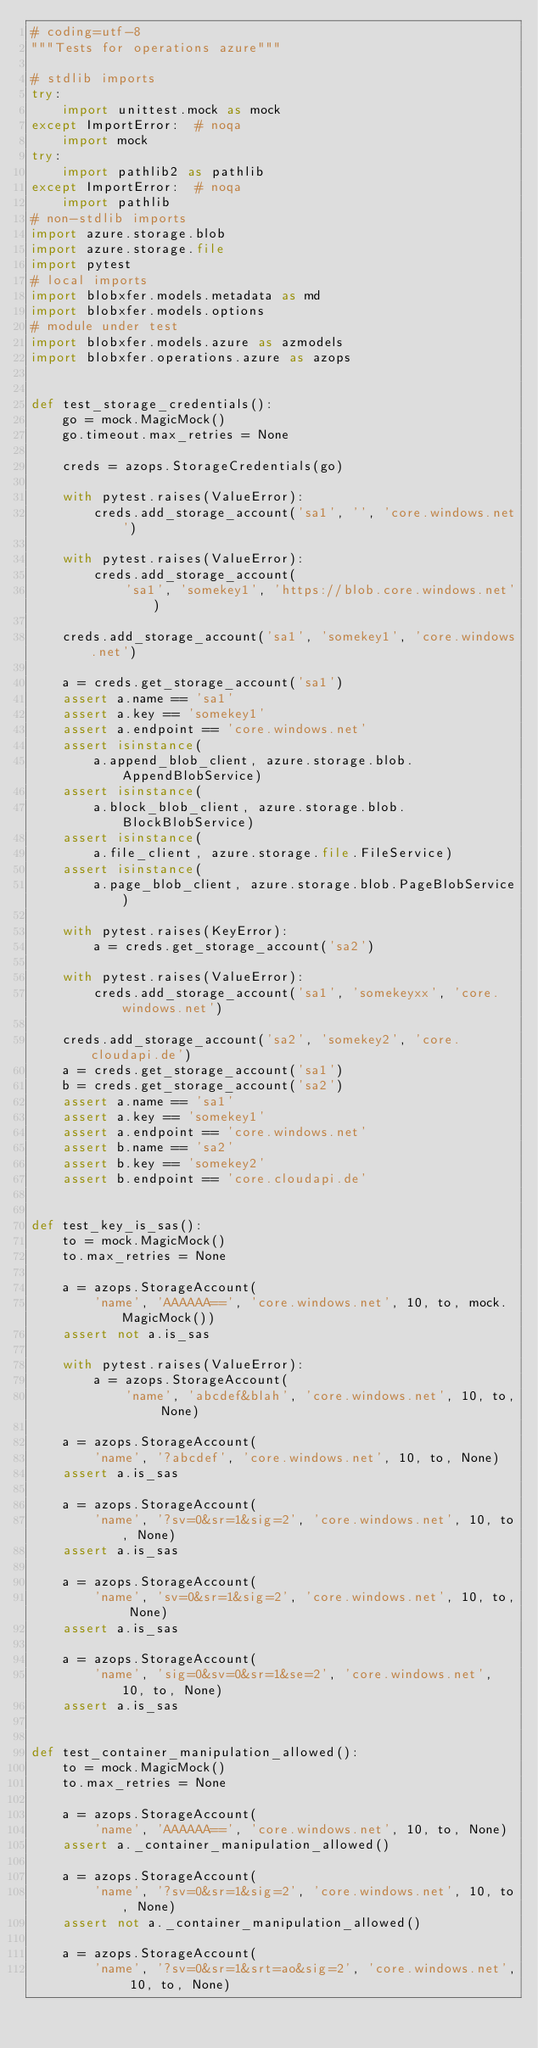<code> <loc_0><loc_0><loc_500><loc_500><_Python_># coding=utf-8
"""Tests for operations azure"""

# stdlib imports
try:
    import unittest.mock as mock
except ImportError:  # noqa
    import mock
try:
    import pathlib2 as pathlib
except ImportError:  # noqa
    import pathlib
# non-stdlib imports
import azure.storage.blob
import azure.storage.file
import pytest
# local imports
import blobxfer.models.metadata as md
import blobxfer.models.options
# module under test
import blobxfer.models.azure as azmodels
import blobxfer.operations.azure as azops


def test_storage_credentials():
    go = mock.MagicMock()
    go.timeout.max_retries = None

    creds = azops.StorageCredentials(go)

    with pytest.raises(ValueError):
        creds.add_storage_account('sa1', '', 'core.windows.net')

    with pytest.raises(ValueError):
        creds.add_storage_account(
            'sa1', 'somekey1', 'https://blob.core.windows.net')

    creds.add_storage_account('sa1', 'somekey1', 'core.windows.net')

    a = creds.get_storage_account('sa1')
    assert a.name == 'sa1'
    assert a.key == 'somekey1'
    assert a.endpoint == 'core.windows.net'
    assert isinstance(
        a.append_blob_client, azure.storage.blob.AppendBlobService)
    assert isinstance(
        a.block_blob_client, azure.storage.blob.BlockBlobService)
    assert isinstance(
        a.file_client, azure.storage.file.FileService)
    assert isinstance(
        a.page_blob_client, azure.storage.blob.PageBlobService)

    with pytest.raises(KeyError):
        a = creds.get_storage_account('sa2')

    with pytest.raises(ValueError):
        creds.add_storage_account('sa1', 'somekeyxx', 'core.windows.net')

    creds.add_storage_account('sa2', 'somekey2', 'core.cloudapi.de')
    a = creds.get_storage_account('sa1')
    b = creds.get_storage_account('sa2')
    assert a.name == 'sa1'
    assert a.key == 'somekey1'
    assert a.endpoint == 'core.windows.net'
    assert b.name == 'sa2'
    assert b.key == 'somekey2'
    assert b.endpoint == 'core.cloudapi.de'


def test_key_is_sas():
    to = mock.MagicMock()
    to.max_retries = None

    a = azops.StorageAccount(
        'name', 'AAAAAA==', 'core.windows.net', 10, to, mock.MagicMock())
    assert not a.is_sas

    with pytest.raises(ValueError):
        a = azops.StorageAccount(
            'name', 'abcdef&blah', 'core.windows.net', 10, to, None)

    a = azops.StorageAccount(
        'name', '?abcdef', 'core.windows.net', 10, to, None)
    assert a.is_sas

    a = azops.StorageAccount(
        'name', '?sv=0&sr=1&sig=2', 'core.windows.net', 10, to, None)
    assert a.is_sas

    a = azops.StorageAccount(
        'name', 'sv=0&sr=1&sig=2', 'core.windows.net', 10, to, None)
    assert a.is_sas

    a = azops.StorageAccount(
        'name', 'sig=0&sv=0&sr=1&se=2', 'core.windows.net', 10, to, None)
    assert a.is_sas


def test_container_manipulation_allowed():
    to = mock.MagicMock()
    to.max_retries = None

    a = azops.StorageAccount(
        'name', 'AAAAAA==', 'core.windows.net', 10, to, None)
    assert a._container_manipulation_allowed()

    a = azops.StorageAccount(
        'name', '?sv=0&sr=1&sig=2', 'core.windows.net', 10, to, None)
    assert not a._container_manipulation_allowed()

    a = azops.StorageAccount(
        'name', '?sv=0&sr=1&srt=ao&sig=2', 'core.windows.net', 10, to, None)</code> 